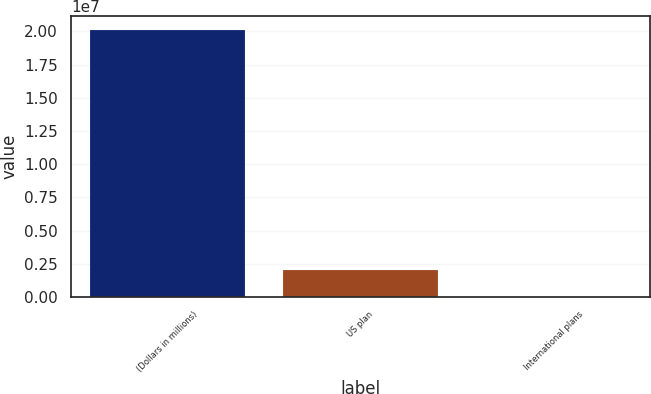Convert chart to OTSL. <chart><loc_0><loc_0><loc_500><loc_500><bar_chart><fcel>(Dollars in millions)<fcel>US plan<fcel>International plans<nl><fcel>2.0132e+07<fcel>2.01324e+06<fcel>46<nl></chart> 